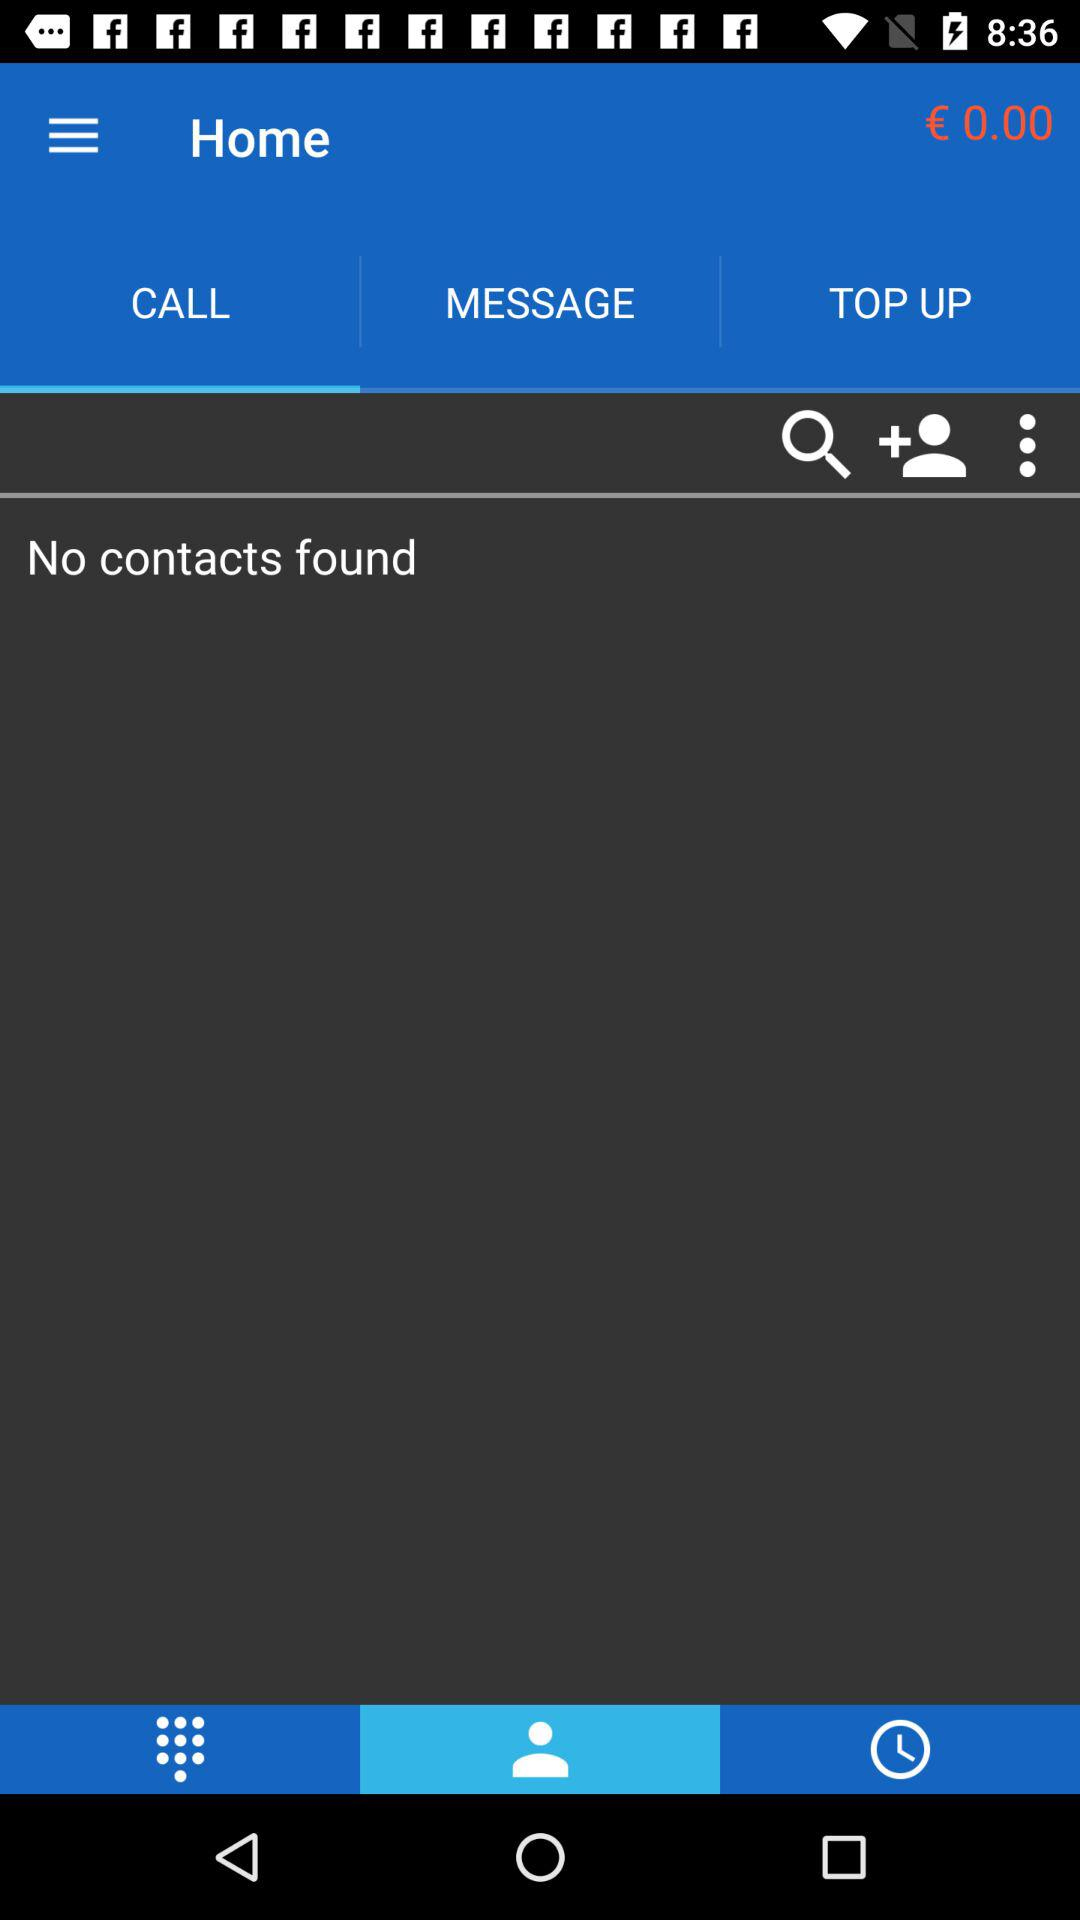Which tab is selected? The selected tabs are "CALL" and "Contacts". 